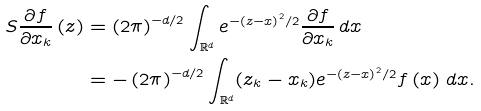Convert formula to latex. <formula><loc_0><loc_0><loc_500><loc_500>S \frac { \partial f } { \partial x _ { k } } \left ( z \right ) & = \left ( 2 \pi \right ) ^ { - d / 2 } \int _ { \mathbb { R } ^ { d } } e ^ { - \left ( z - x \right ) ^ { 2 } / 2 } \frac { \partial f } { \partial x _ { k } } \, d x \\ & = - \left ( 2 \pi \right ) ^ { - d / 2 } \int _ { \mathbb { R } ^ { d } } ( z _ { k } - x _ { k } ) e ^ { - \left ( z - x \right ) ^ { 2 } / 2 } f \left ( x \right ) \, d x .</formula> 